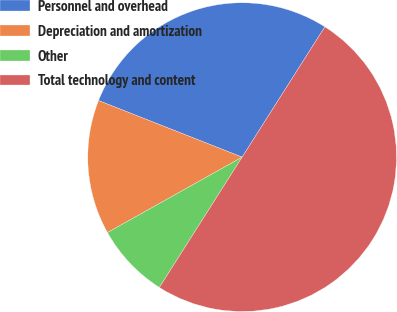Convert chart. <chart><loc_0><loc_0><loc_500><loc_500><pie_chart><fcel>Personnel and overhead<fcel>Depreciation and amortization<fcel>Other<fcel>Total technology and content<nl><fcel>28.03%<fcel>14.1%<fcel>7.87%<fcel>50.0%<nl></chart> 